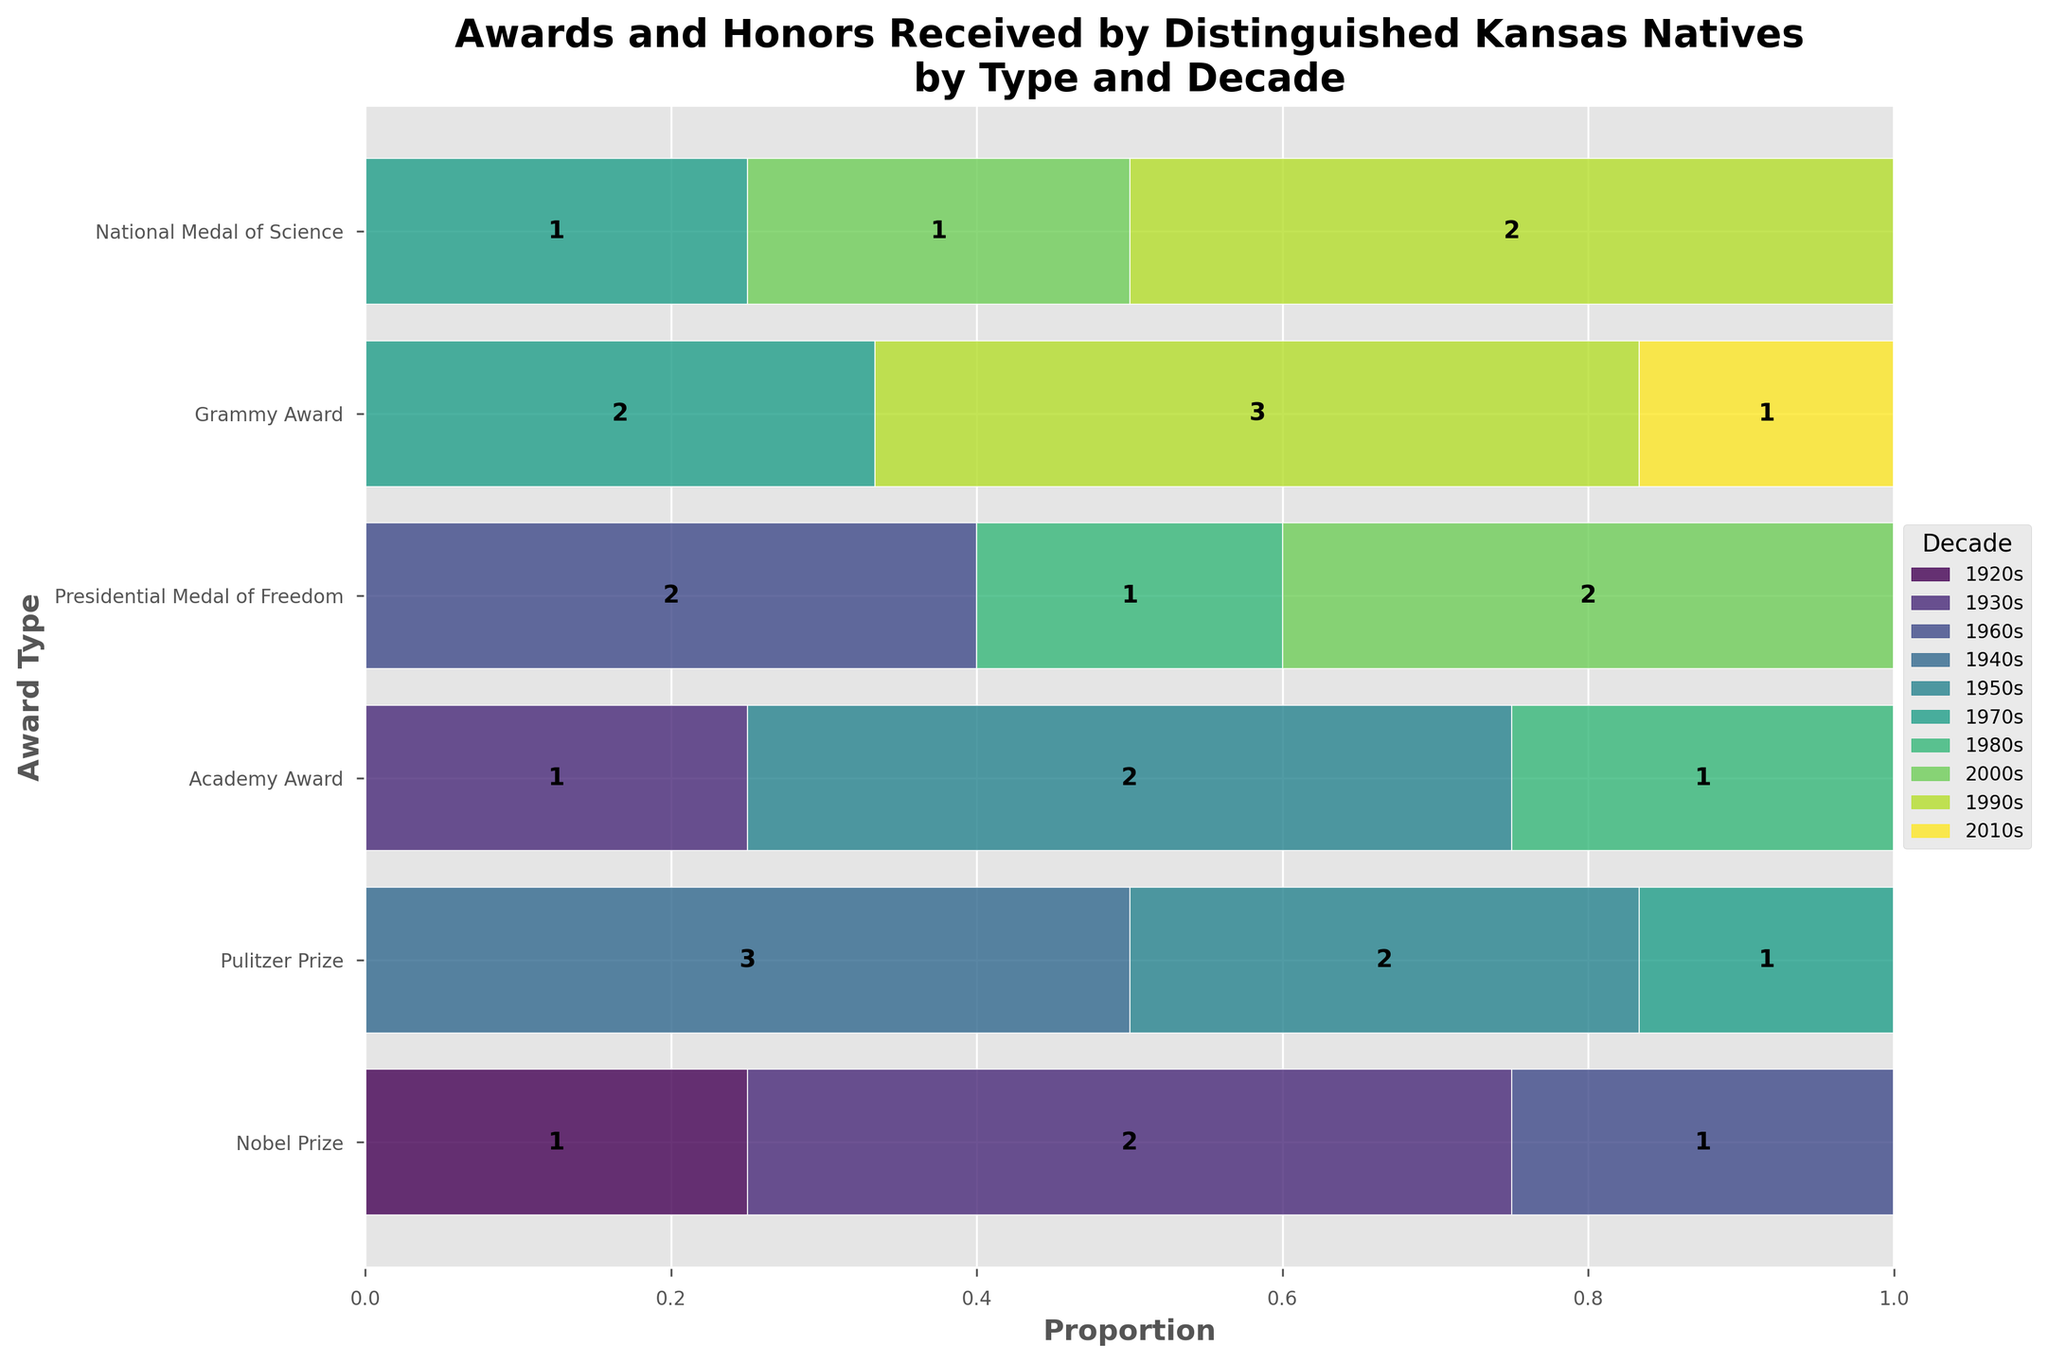Which award type appears most frequently in the 1990s? By looking at the figure and focusing on the 1990s section, the Grammy Award appears to have the largest proportion in that decade. This is indicated by the segment's relative size compared to other sections in the same decade.
Answer: Grammy Award How many Nobel Prizes were awarded in total from the 1920s to the 1960s? Add the counts from the 1920s (1), 1930s (2), and 1960s (1). Thus, 1 + 2 + 1 = 4.
Answer: 4 Which decade had the highest number of awards received by Kansans? Compare the widths of each segment across all decades. The 1990s decade appears to have the highest overall number of awards due to the greater combined width of its segments.
Answer: 1990s How does the proportion of Pulitzer Prizes in the 1940s compare to the 1950s? Observe the relative bars for Pulitzer Prizes in the 1940s and 1950s. The 1940s segment is larger, indicating more Pulitzer Prizes were awarded compared to the 1950s.
Answer: More in 1940s In which decade did Kansans receive the fewest Grammy Awards? Check the segments representing the Grammy Awards for each decade. The 2010s and 1970s both show small segments, with the 2010s having only 1 Grammy Award.
Answer: 2010s Which award type had a consistent count over two consecutive decades? Look for segments that do not change their size between two consecutive decades. The National Medal of Science had 2 awards both in the 1990s and 2000s.
Answer: National Medal of Science 